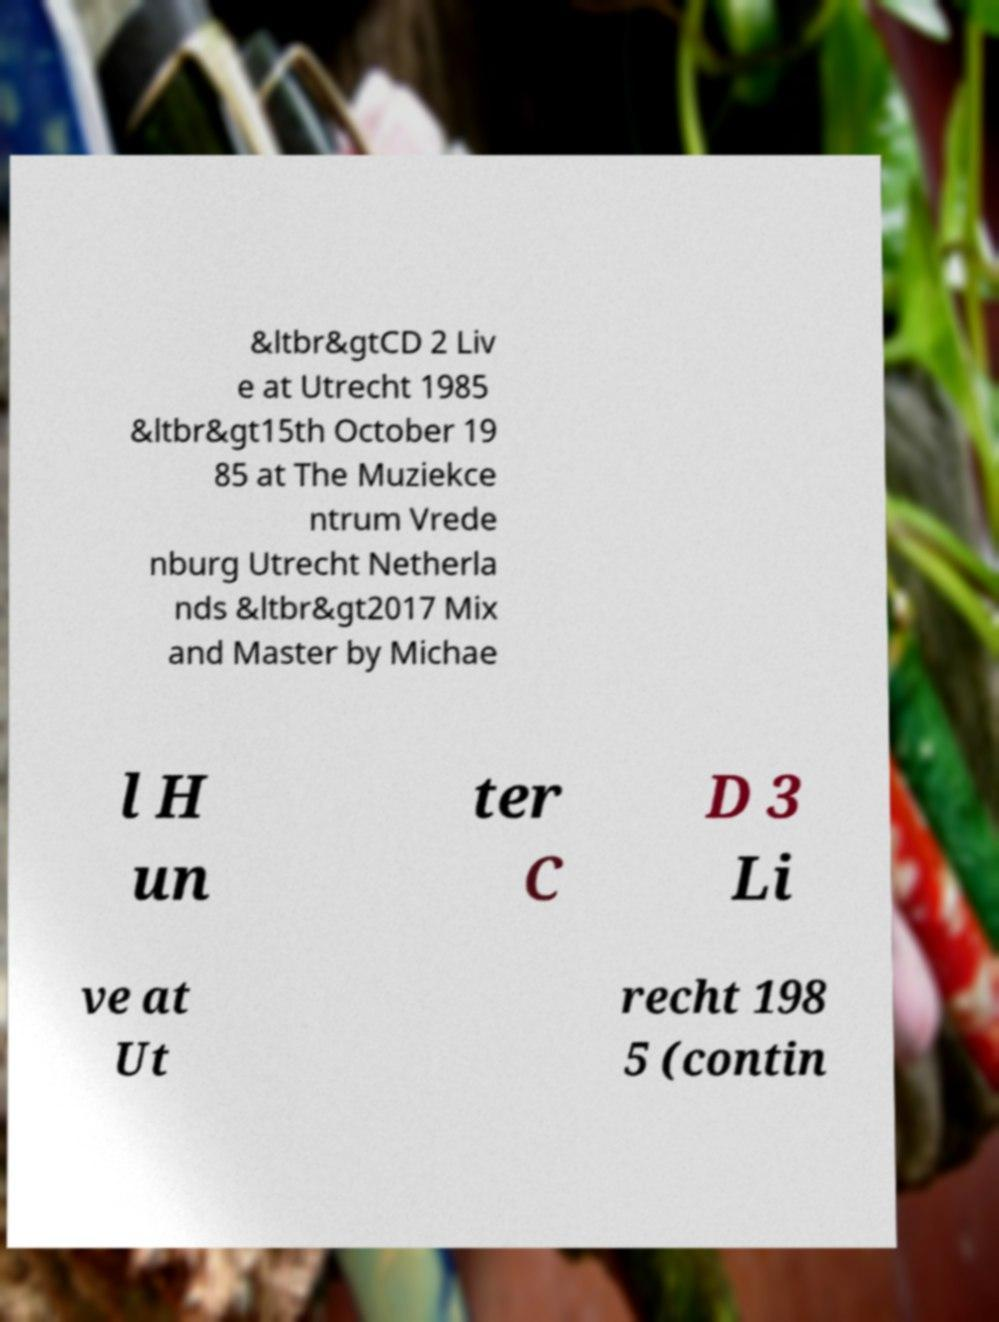Please read and relay the text visible in this image. What does it say? &ltbr&gtCD 2 Liv e at Utrecht 1985 &ltbr&gt15th October 19 85 at The Muziekce ntrum Vrede nburg Utrecht Netherla nds &ltbr&gt2017 Mix and Master by Michae l H un ter C D 3 Li ve at Ut recht 198 5 (contin 